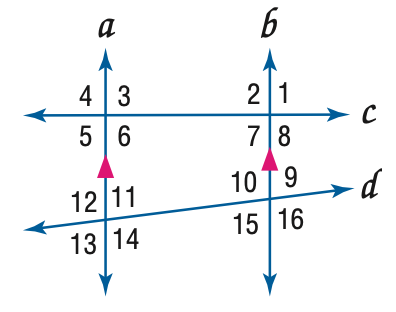Answer the mathemtical geometry problem and directly provide the correct option letter.
Question: In the figure, m \angle 4 = 104, m \angle 14 = 118. Find the measure of \angle 7.
Choices: A: 66 B: 76 C: 104 D: 118 B 